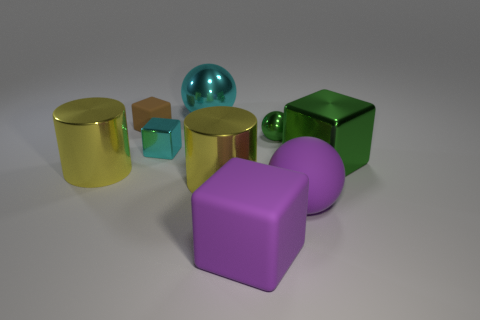Subtract all cyan cubes. How many cubes are left? 3 Subtract all metallic balls. How many balls are left? 1 Subtract 1 cyan cubes. How many objects are left? 8 Subtract all balls. How many objects are left? 6 Subtract 2 cylinders. How many cylinders are left? 0 Subtract all blue blocks. Subtract all yellow spheres. How many blocks are left? 4 Subtract all blue spheres. How many red blocks are left? 0 Subtract all cyan objects. Subtract all large purple rubber objects. How many objects are left? 5 Add 4 cyan shiny balls. How many cyan shiny balls are left? 5 Add 2 yellow objects. How many yellow objects exist? 4 